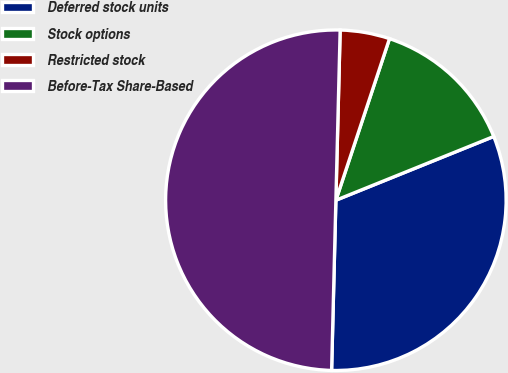<chart> <loc_0><loc_0><loc_500><loc_500><pie_chart><fcel>Deferred stock units<fcel>Stock options<fcel>Restricted stock<fcel>Before-Tax Share-Based<nl><fcel>31.51%<fcel>13.79%<fcel>4.7%<fcel>50.0%<nl></chart> 